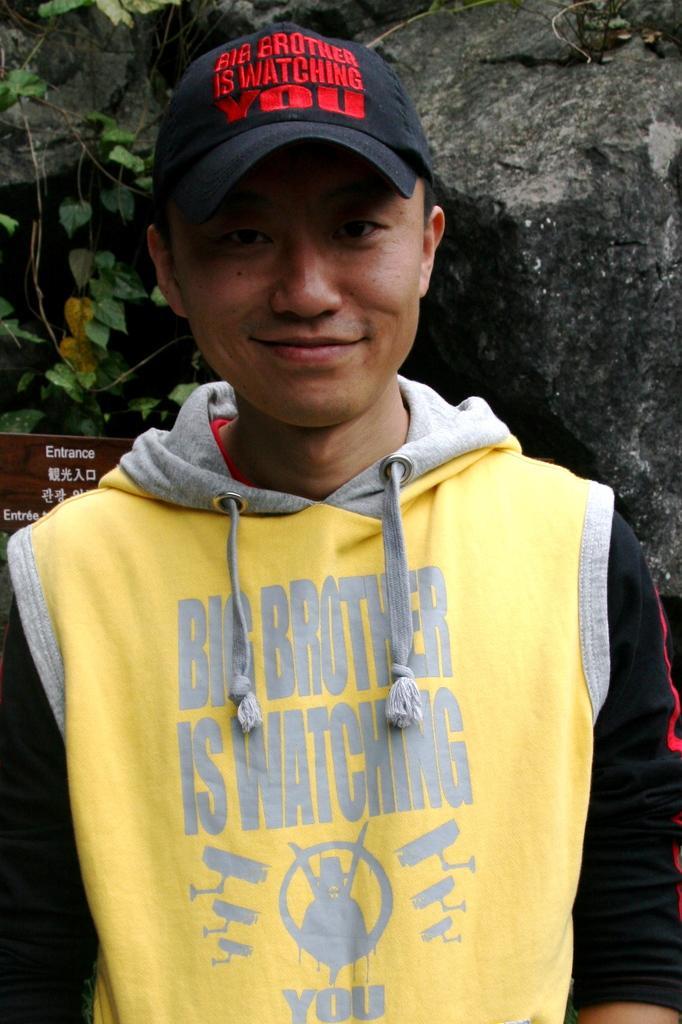Describe this image in one or two sentences. In this image we can see a person wearing a cap, behind him there is a wooden board with some text and in the background we can see some rocks and a plant. 